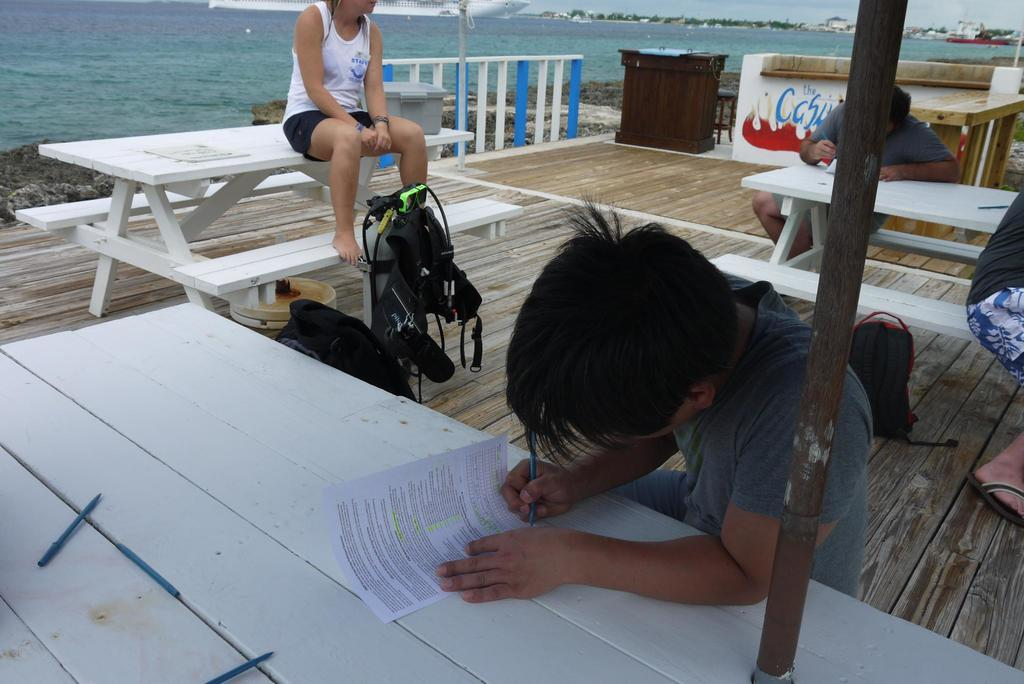How many people are in the image? There are three people in the image. What is the woman doing in the image? The woman is sitting on a table. How are the two men positioned in the image? The two men are sitting one behind the other. What are the men doing in the image? The men are writing on a paper. Where is the image taken? The location is a beach. What can be seen in the background of the image? A partial ship is visible in the image. What type of vest is the woman wearing in the image? The image does not show the woman wearing a vest, so it cannot be determined from the image. 